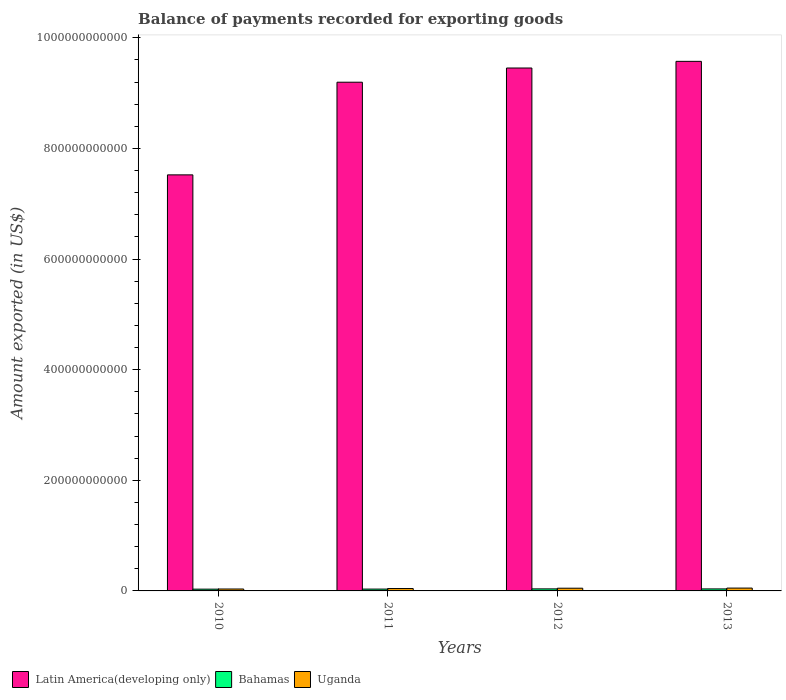How many different coloured bars are there?
Your response must be concise. 3. How many groups of bars are there?
Ensure brevity in your answer.  4. Are the number of bars per tick equal to the number of legend labels?
Give a very brief answer. Yes. What is the amount exported in Bahamas in 2013?
Provide a succinct answer. 3.63e+09. Across all years, what is the maximum amount exported in Bahamas?
Provide a succinct answer. 3.68e+09. Across all years, what is the minimum amount exported in Latin America(developing only)?
Offer a terse response. 7.52e+11. In which year was the amount exported in Bahamas maximum?
Your answer should be compact. 2012. What is the total amount exported in Uganda in the graph?
Make the answer very short. 1.78e+1. What is the difference between the amount exported in Uganda in 2010 and that in 2013?
Your response must be concise. -1.67e+09. What is the difference between the amount exported in Bahamas in 2011 and the amount exported in Uganda in 2010?
Offer a very short reply. -1.40e+08. What is the average amount exported in Latin America(developing only) per year?
Offer a terse response. 8.94e+11. In the year 2010, what is the difference between the amount exported in Bahamas and amount exported in Uganda?
Make the answer very short. -2.72e+08. What is the ratio of the amount exported in Latin America(developing only) in 2011 to that in 2013?
Make the answer very short. 0.96. Is the difference between the amount exported in Bahamas in 2012 and 2013 greater than the difference between the amount exported in Uganda in 2012 and 2013?
Offer a terse response. Yes. What is the difference between the highest and the second highest amount exported in Bahamas?
Make the answer very short. 4.92e+07. What is the difference between the highest and the lowest amount exported in Latin America(developing only)?
Offer a terse response. 2.05e+11. In how many years, is the amount exported in Uganda greater than the average amount exported in Uganda taken over all years?
Your answer should be very brief. 2. What does the 2nd bar from the left in 2010 represents?
Make the answer very short. Bahamas. What does the 2nd bar from the right in 2013 represents?
Provide a short and direct response. Bahamas. How many bars are there?
Your answer should be compact. 12. Are all the bars in the graph horizontal?
Ensure brevity in your answer.  No. What is the difference between two consecutive major ticks on the Y-axis?
Provide a succinct answer. 2.00e+11. Does the graph contain grids?
Your answer should be very brief. No. How are the legend labels stacked?
Provide a succinct answer. Horizontal. What is the title of the graph?
Ensure brevity in your answer.  Balance of payments recorded for exporting goods. Does "Saudi Arabia" appear as one of the legend labels in the graph?
Your response must be concise. No. What is the label or title of the Y-axis?
Offer a very short reply. Amount exported (in US$). What is the Amount exported (in US$) of Latin America(developing only) in 2010?
Offer a very short reply. 7.52e+11. What is the Amount exported (in US$) of Bahamas in 2010?
Your answer should be very brief. 3.20e+09. What is the Amount exported (in US$) in Uganda in 2010?
Your response must be concise. 3.47e+09. What is the Amount exported (in US$) of Latin America(developing only) in 2011?
Offer a terse response. 9.20e+11. What is the Amount exported (in US$) in Bahamas in 2011?
Your answer should be very brief. 3.33e+09. What is the Amount exported (in US$) of Uganda in 2011?
Your answer should be compact. 4.30e+09. What is the Amount exported (in US$) in Latin America(developing only) in 2012?
Make the answer very short. 9.45e+11. What is the Amount exported (in US$) in Bahamas in 2012?
Give a very brief answer. 3.68e+09. What is the Amount exported (in US$) in Uganda in 2012?
Your answer should be compact. 4.90e+09. What is the Amount exported (in US$) of Latin America(developing only) in 2013?
Offer a very short reply. 9.57e+11. What is the Amount exported (in US$) in Bahamas in 2013?
Your answer should be very brief. 3.63e+09. What is the Amount exported (in US$) in Uganda in 2013?
Your answer should be compact. 5.14e+09. Across all years, what is the maximum Amount exported (in US$) in Latin America(developing only)?
Ensure brevity in your answer.  9.57e+11. Across all years, what is the maximum Amount exported (in US$) in Bahamas?
Offer a very short reply. 3.68e+09. Across all years, what is the maximum Amount exported (in US$) in Uganda?
Keep it short and to the point. 5.14e+09. Across all years, what is the minimum Amount exported (in US$) in Latin America(developing only)?
Offer a very short reply. 7.52e+11. Across all years, what is the minimum Amount exported (in US$) of Bahamas?
Offer a terse response. 3.20e+09. Across all years, what is the minimum Amount exported (in US$) of Uganda?
Ensure brevity in your answer.  3.47e+09. What is the total Amount exported (in US$) in Latin America(developing only) in the graph?
Your response must be concise. 3.57e+12. What is the total Amount exported (in US$) in Bahamas in the graph?
Your answer should be very brief. 1.38e+1. What is the total Amount exported (in US$) of Uganda in the graph?
Your answer should be very brief. 1.78e+1. What is the difference between the Amount exported (in US$) of Latin America(developing only) in 2010 and that in 2011?
Keep it short and to the point. -1.67e+11. What is the difference between the Amount exported (in US$) in Bahamas in 2010 and that in 2011?
Your answer should be compact. -1.31e+08. What is the difference between the Amount exported (in US$) in Uganda in 2010 and that in 2011?
Your response must be concise. -8.30e+08. What is the difference between the Amount exported (in US$) in Latin America(developing only) in 2010 and that in 2012?
Provide a succinct answer. -1.93e+11. What is the difference between the Amount exported (in US$) in Bahamas in 2010 and that in 2012?
Offer a terse response. -4.79e+08. What is the difference between the Amount exported (in US$) in Uganda in 2010 and that in 2012?
Your response must be concise. -1.43e+09. What is the difference between the Amount exported (in US$) in Latin America(developing only) in 2010 and that in 2013?
Ensure brevity in your answer.  -2.05e+11. What is the difference between the Amount exported (in US$) of Bahamas in 2010 and that in 2013?
Provide a short and direct response. -4.30e+08. What is the difference between the Amount exported (in US$) in Uganda in 2010 and that in 2013?
Your answer should be compact. -1.67e+09. What is the difference between the Amount exported (in US$) in Latin America(developing only) in 2011 and that in 2012?
Give a very brief answer. -2.57e+1. What is the difference between the Amount exported (in US$) in Bahamas in 2011 and that in 2012?
Your response must be concise. -3.48e+08. What is the difference between the Amount exported (in US$) in Uganda in 2011 and that in 2012?
Offer a very short reply. -6.04e+08. What is the difference between the Amount exported (in US$) in Latin America(developing only) in 2011 and that in 2013?
Give a very brief answer. -3.77e+1. What is the difference between the Amount exported (in US$) of Bahamas in 2011 and that in 2013?
Make the answer very short. -2.99e+08. What is the difference between the Amount exported (in US$) of Uganda in 2011 and that in 2013?
Keep it short and to the point. -8.39e+08. What is the difference between the Amount exported (in US$) of Latin America(developing only) in 2012 and that in 2013?
Provide a short and direct response. -1.20e+1. What is the difference between the Amount exported (in US$) in Bahamas in 2012 and that in 2013?
Provide a short and direct response. 4.92e+07. What is the difference between the Amount exported (in US$) in Uganda in 2012 and that in 2013?
Give a very brief answer. -2.35e+08. What is the difference between the Amount exported (in US$) in Latin America(developing only) in 2010 and the Amount exported (in US$) in Bahamas in 2011?
Keep it short and to the point. 7.49e+11. What is the difference between the Amount exported (in US$) in Latin America(developing only) in 2010 and the Amount exported (in US$) in Uganda in 2011?
Ensure brevity in your answer.  7.48e+11. What is the difference between the Amount exported (in US$) of Bahamas in 2010 and the Amount exported (in US$) of Uganda in 2011?
Provide a succinct answer. -1.10e+09. What is the difference between the Amount exported (in US$) in Latin America(developing only) in 2010 and the Amount exported (in US$) in Bahamas in 2012?
Give a very brief answer. 7.49e+11. What is the difference between the Amount exported (in US$) of Latin America(developing only) in 2010 and the Amount exported (in US$) of Uganda in 2012?
Your answer should be compact. 7.47e+11. What is the difference between the Amount exported (in US$) of Bahamas in 2010 and the Amount exported (in US$) of Uganda in 2012?
Provide a succinct answer. -1.71e+09. What is the difference between the Amount exported (in US$) in Latin America(developing only) in 2010 and the Amount exported (in US$) in Bahamas in 2013?
Provide a succinct answer. 7.49e+11. What is the difference between the Amount exported (in US$) of Latin America(developing only) in 2010 and the Amount exported (in US$) of Uganda in 2013?
Keep it short and to the point. 7.47e+11. What is the difference between the Amount exported (in US$) in Bahamas in 2010 and the Amount exported (in US$) in Uganda in 2013?
Your answer should be very brief. -1.94e+09. What is the difference between the Amount exported (in US$) of Latin America(developing only) in 2011 and the Amount exported (in US$) of Bahamas in 2012?
Give a very brief answer. 9.16e+11. What is the difference between the Amount exported (in US$) in Latin America(developing only) in 2011 and the Amount exported (in US$) in Uganda in 2012?
Ensure brevity in your answer.  9.15e+11. What is the difference between the Amount exported (in US$) in Bahamas in 2011 and the Amount exported (in US$) in Uganda in 2012?
Give a very brief answer. -1.57e+09. What is the difference between the Amount exported (in US$) of Latin America(developing only) in 2011 and the Amount exported (in US$) of Bahamas in 2013?
Your answer should be very brief. 9.16e+11. What is the difference between the Amount exported (in US$) of Latin America(developing only) in 2011 and the Amount exported (in US$) of Uganda in 2013?
Provide a succinct answer. 9.15e+11. What is the difference between the Amount exported (in US$) in Bahamas in 2011 and the Amount exported (in US$) in Uganda in 2013?
Provide a succinct answer. -1.81e+09. What is the difference between the Amount exported (in US$) in Latin America(developing only) in 2012 and the Amount exported (in US$) in Bahamas in 2013?
Make the answer very short. 9.42e+11. What is the difference between the Amount exported (in US$) in Latin America(developing only) in 2012 and the Amount exported (in US$) in Uganda in 2013?
Your answer should be very brief. 9.40e+11. What is the difference between the Amount exported (in US$) in Bahamas in 2012 and the Amount exported (in US$) in Uganda in 2013?
Provide a succinct answer. -1.46e+09. What is the average Amount exported (in US$) in Latin America(developing only) per year?
Your answer should be very brief. 8.94e+11. What is the average Amount exported (in US$) of Bahamas per year?
Keep it short and to the point. 3.46e+09. What is the average Amount exported (in US$) in Uganda per year?
Your answer should be very brief. 4.45e+09. In the year 2010, what is the difference between the Amount exported (in US$) of Latin America(developing only) and Amount exported (in US$) of Bahamas?
Provide a short and direct response. 7.49e+11. In the year 2010, what is the difference between the Amount exported (in US$) of Latin America(developing only) and Amount exported (in US$) of Uganda?
Provide a succinct answer. 7.49e+11. In the year 2010, what is the difference between the Amount exported (in US$) in Bahamas and Amount exported (in US$) in Uganda?
Ensure brevity in your answer.  -2.72e+08. In the year 2011, what is the difference between the Amount exported (in US$) of Latin America(developing only) and Amount exported (in US$) of Bahamas?
Your answer should be very brief. 9.16e+11. In the year 2011, what is the difference between the Amount exported (in US$) of Latin America(developing only) and Amount exported (in US$) of Uganda?
Keep it short and to the point. 9.15e+11. In the year 2011, what is the difference between the Amount exported (in US$) of Bahamas and Amount exported (in US$) of Uganda?
Offer a very short reply. -9.70e+08. In the year 2012, what is the difference between the Amount exported (in US$) in Latin America(developing only) and Amount exported (in US$) in Bahamas?
Your answer should be compact. 9.42e+11. In the year 2012, what is the difference between the Amount exported (in US$) in Latin America(developing only) and Amount exported (in US$) in Uganda?
Offer a terse response. 9.40e+11. In the year 2012, what is the difference between the Amount exported (in US$) of Bahamas and Amount exported (in US$) of Uganda?
Provide a short and direct response. -1.23e+09. In the year 2013, what is the difference between the Amount exported (in US$) of Latin America(developing only) and Amount exported (in US$) of Bahamas?
Offer a very short reply. 9.54e+11. In the year 2013, what is the difference between the Amount exported (in US$) of Latin America(developing only) and Amount exported (in US$) of Uganda?
Your answer should be very brief. 9.52e+11. In the year 2013, what is the difference between the Amount exported (in US$) of Bahamas and Amount exported (in US$) of Uganda?
Provide a succinct answer. -1.51e+09. What is the ratio of the Amount exported (in US$) in Latin America(developing only) in 2010 to that in 2011?
Give a very brief answer. 0.82. What is the ratio of the Amount exported (in US$) of Bahamas in 2010 to that in 2011?
Keep it short and to the point. 0.96. What is the ratio of the Amount exported (in US$) in Uganda in 2010 to that in 2011?
Your response must be concise. 0.81. What is the ratio of the Amount exported (in US$) in Latin America(developing only) in 2010 to that in 2012?
Provide a succinct answer. 0.8. What is the ratio of the Amount exported (in US$) of Bahamas in 2010 to that in 2012?
Your response must be concise. 0.87. What is the ratio of the Amount exported (in US$) in Uganda in 2010 to that in 2012?
Provide a succinct answer. 0.71. What is the ratio of the Amount exported (in US$) in Latin America(developing only) in 2010 to that in 2013?
Provide a short and direct response. 0.79. What is the ratio of the Amount exported (in US$) in Bahamas in 2010 to that in 2013?
Offer a terse response. 0.88. What is the ratio of the Amount exported (in US$) of Uganda in 2010 to that in 2013?
Your answer should be very brief. 0.68. What is the ratio of the Amount exported (in US$) in Latin America(developing only) in 2011 to that in 2012?
Offer a very short reply. 0.97. What is the ratio of the Amount exported (in US$) of Bahamas in 2011 to that in 2012?
Your answer should be very brief. 0.91. What is the ratio of the Amount exported (in US$) in Uganda in 2011 to that in 2012?
Your answer should be compact. 0.88. What is the ratio of the Amount exported (in US$) in Latin America(developing only) in 2011 to that in 2013?
Offer a very short reply. 0.96. What is the ratio of the Amount exported (in US$) of Bahamas in 2011 to that in 2013?
Ensure brevity in your answer.  0.92. What is the ratio of the Amount exported (in US$) of Uganda in 2011 to that in 2013?
Your response must be concise. 0.84. What is the ratio of the Amount exported (in US$) in Latin America(developing only) in 2012 to that in 2013?
Keep it short and to the point. 0.99. What is the ratio of the Amount exported (in US$) in Bahamas in 2012 to that in 2013?
Your answer should be compact. 1.01. What is the ratio of the Amount exported (in US$) in Uganda in 2012 to that in 2013?
Offer a terse response. 0.95. What is the difference between the highest and the second highest Amount exported (in US$) in Latin America(developing only)?
Offer a terse response. 1.20e+1. What is the difference between the highest and the second highest Amount exported (in US$) in Bahamas?
Provide a succinct answer. 4.92e+07. What is the difference between the highest and the second highest Amount exported (in US$) of Uganda?
Your response must be concise. 2.35e+08. What is the difference between the highest and the lowest Amount exported (in US$) in Latin America(developing only)?
Keep it short and to the point. 2.05e+11. What is the difference between the highest and the lowest Amount exported (in US$) in Bahamas?
Provide a succinct answer. 4.79e+08. What is the difference between the highest and the lowest Amount exported (in US$) in Uganda?
Offer a terse response. 1.67e+09. 